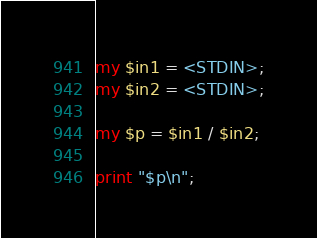<code> <loc_0><loc_0><loc_500><loc_500><_Perl_>my $in1 = <STDIN>;
my $in2 = <STDIN>;

my $p = $in1 / $in2;

print "$p\n";
</code> 